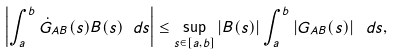Convert formula to latex. <formula><loc_0><loc_0><loc_500><loc_500>\left | \int _ { a } ^ { b } \dot { G } _ { A B } ( s ) B ( s ) \text { } d s \right | \leq \sup _ { s \in [ a , b ] } \left | B ( s ) \right | \int _ { a } ^ { b } \left | G _ { A B } ( s ) \right | \text { } d s ,</formula> 